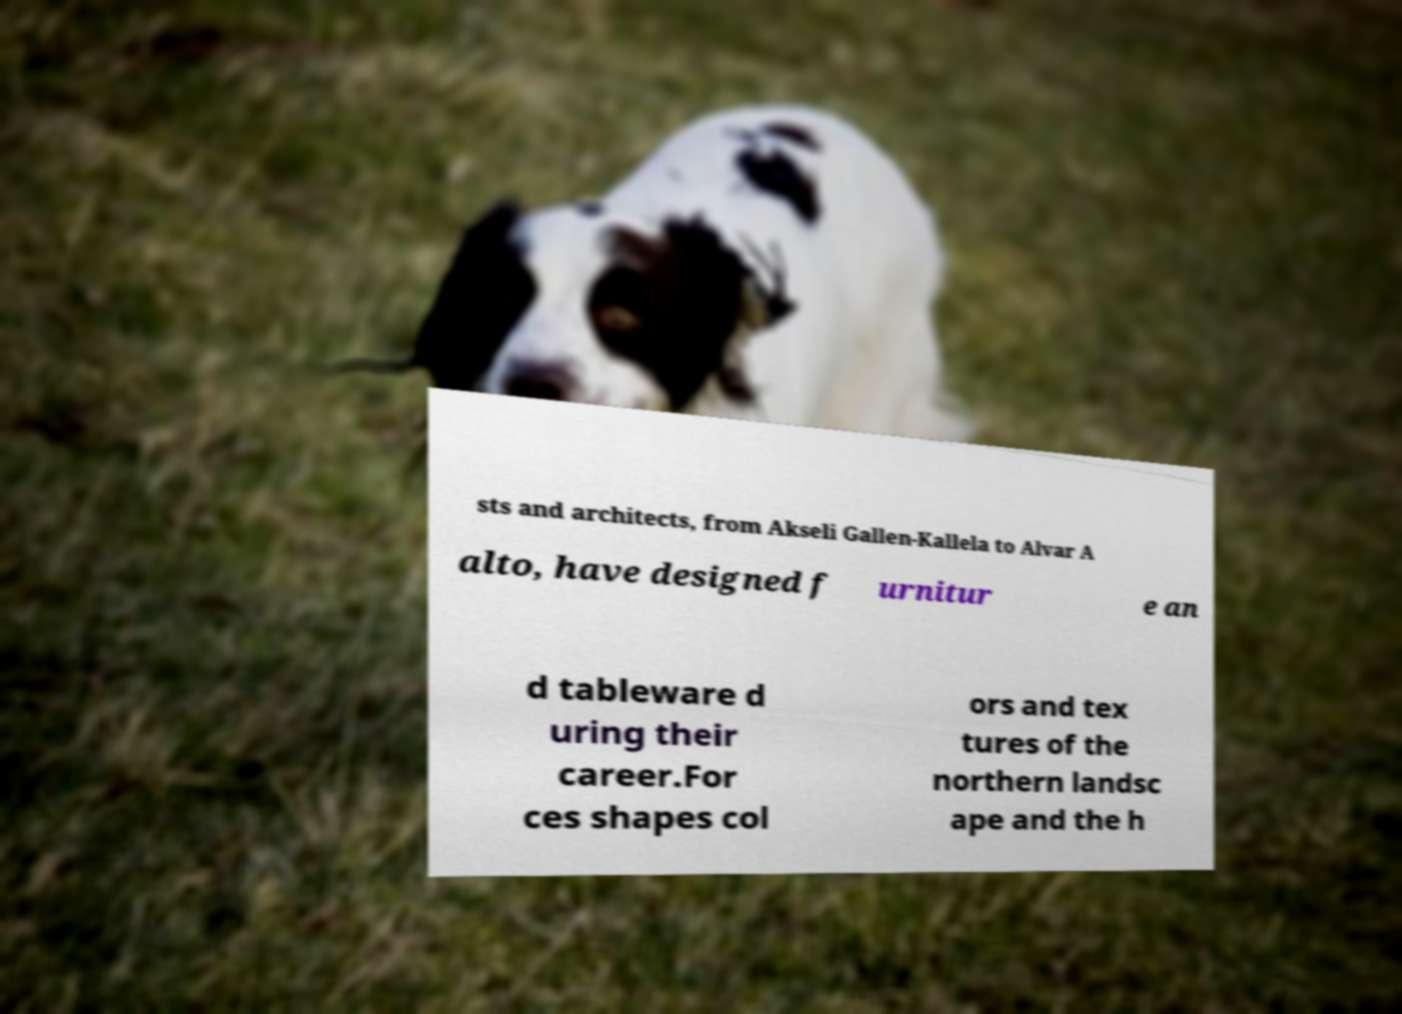Could you assist in decoding the text presented in this image and type it out clearly? sts and architects, from Akseli Gallen-Kallela to Alvar A alto, have designed f urnitur e an d tableware d uring their career.For ces shapes col ors and tex tures of the northern landsc ape and the h 